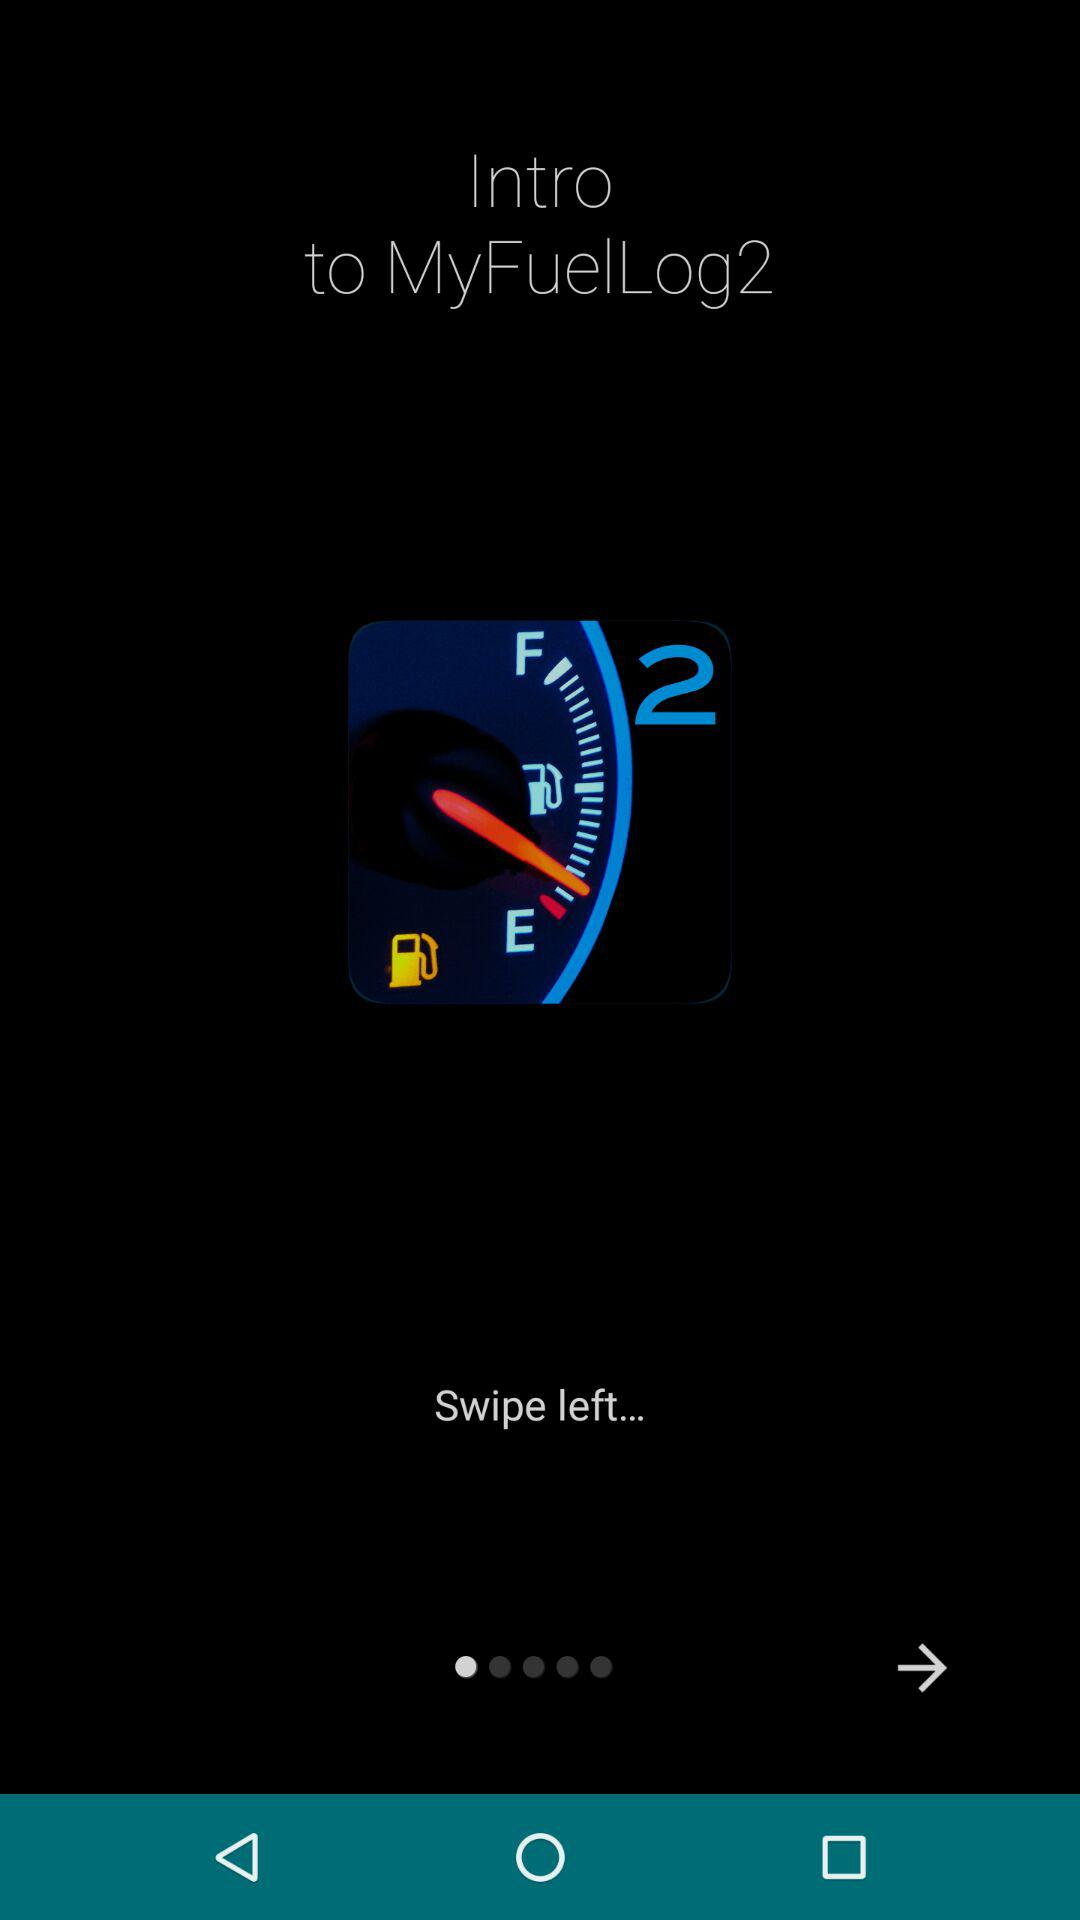What is the name of the application? The name of the application is "MyFuelLog2". 